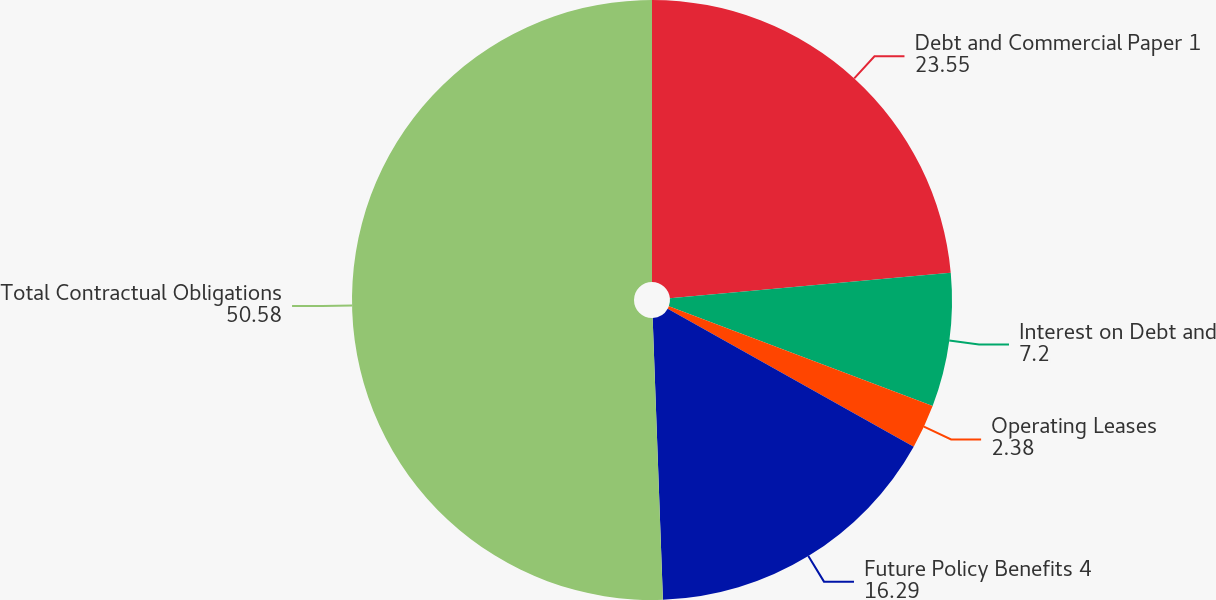Convert chart to OTSL. <chart><loc_0><loc_0><loc_500><loc_500><pie_chart><fcel>Debt and Commercial Paper 1<fcel>Interest on Debt and<fcel>Operating Leases<fcel>Future Policy Benefits 4<fcel>Total Contractual Obligations<nl><fcel>23.55%<fcel>7.2%<fcel>2.38%<fcel>16.29%<fcel>50.58%<nl></chart> 